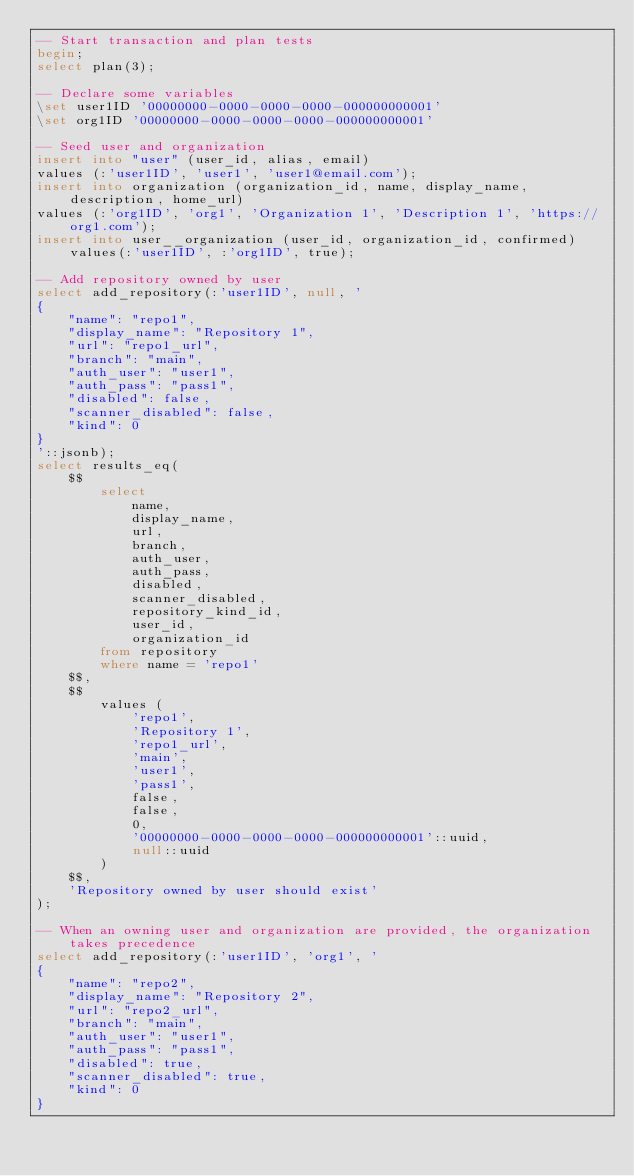Convert code to text. <code><loc_0><loc_0><loc_500><loc_500><_SQL_>-- Start transaction and plan tests
begin;
select plan(3);

-- Declare some variables
\set user1ID '00000000-0000-0000-0000-000000000001'
\set org1ID '00000000-0000-0000-0000-000000000001'

-- Seed user and organization
insert into "user" (user_id, alias, email)
values (:'user1ID', 'user1', 'user1@email.com');
insert into organization (organization_id, name, display_name, description, home_url)
values (:'org1ID', 'org1', 'Organization 1', 'Description 1', 'https://org1.com');
insert into user__organization (user_id, organization_id, confirmed) values(:'user1ID', :'org1ID', true);

-- Add repository owned by user
select add_repository(:'user1ID', null, '
{
    "name": "repo1",
    "display_name": "Repository 1",
    "url": "repo1_url",
    "branch": "main",
    "auth_user": "user1",
    "auth_pass": "pass1",
    "disabled": false,
    "scanner_disabled": false,
    "kind": 0
}
'::jsonb);
select results_eq(
    $$
        select
            name,
            display_name,
            url,
            branch,
            auth_user,
            auth_pass,
            disabled,
            scanner_disabled,
            repository_kind_id,
            user_id,
            organization_id
        from repository
        where name = 'repo1'
    $$,
    $$
        values (
            'repo1',
            'Repository 1',
            'repo1_url',
            'main',
            'user1',
            'pass1',
            false,
            false,
            0,
            '00000000-0000-0000-0000-000000000001'::uuid,
            null::uuid
        )
    $$,
    'Repository owned by user should exist'
);

-- When an owning user and organization are provided, the organization takes precedence
select add_repository(:'user1ID', 'org1', '
{
    "name": "repo2",
    "display_name": "Repository 2",
    "url": "repo2_url",
    "branch": "main",
    "auth_user": "user1",
    "auth_pass": "pass1",
    "disabled": true,
    "scanner_disabled": true,
    "kind": 0
}</code> 